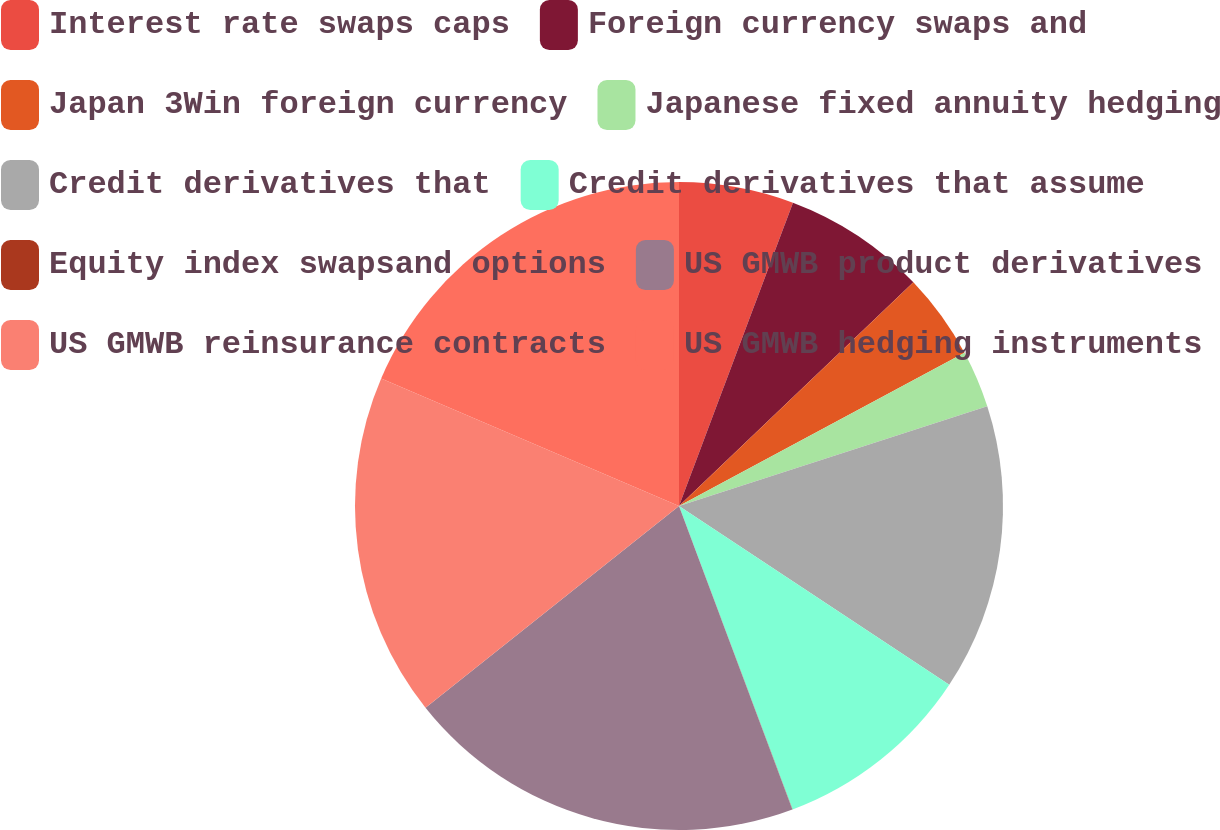Convert chart to OTSL. <chart><loc_0><loc_0><loc_500><loc_500><pie_chart><fcel>Interest rate swaps caps<fcel>Foreign currency swaps and<fcel>Japan 3Win foreign currency<fcel>Japanese fixed annuity hedging<fcel>Credit derivatives that<fcel>Credit derivatives that assume<fcel>Equity index swapsand options<fcel>US GMWB product derivatives<fcel>US GMWB reinsurance contracts<fcel>US GMWB hedging instruments<nl><fcel>5.72%<fcel>7.15%<fcel>4.29%<fcel>2.86%<fcel>14.28%<fcel>10.0%<fcel>0.01%<fcel>19.99%<fcel>17.14%<fcel>18.56%<nl></chart> 